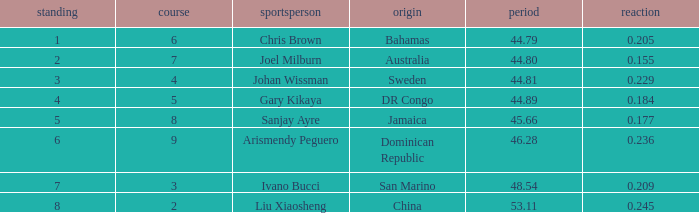Can you parse all the data within this table? {'header': ['standing', 'course', 'sportsperson', 'origin', 'period', 'reaction'], 'rows': [['1', '6', 'Chris Brown', 'Bahamas', '44.79', '0.205'], ['2', '7', 'Joel Milburn', 'Australia', '44.80', '0.155'], ['3', '4', 'Johan Wissman', 'Sweden', '44.81', '0.229'], ['4', '5', 'Gary Kikaya', 'DR Congo', '44.89', '0.184'], ['5', '8', 'Sanjay Ayre', 'Jamaica', '45.66', '0.177'], ['6', '9', 'Arismendy Peguero', 'Dominican Republic', '46.28', '0.236'], ['7', '3', 'Ivano Bucci', 'San Marino', '48.54', '0.209'], ['8', '2', 'Liu Xiaosheng', 'China', '53.11', '0.245']]} How many total Rank listings have Liu Xiaosheng listed as the athlete with a react entry that is smaller than 0.245? 0.0. 